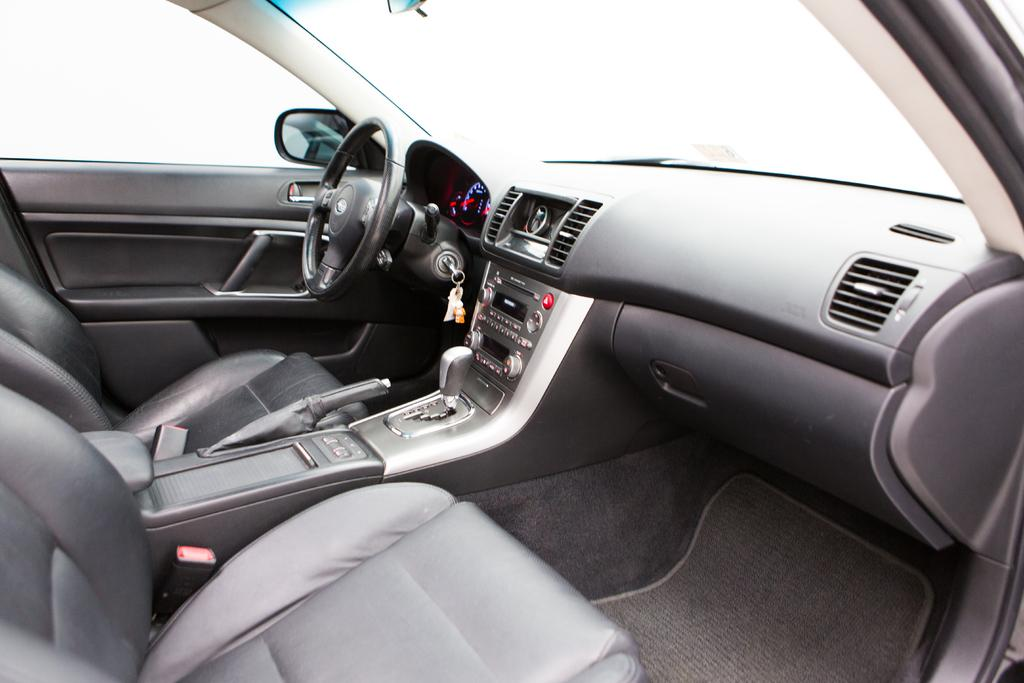What type of vehicle is shown in the image? The image shows the interior of a car. What is the main control device in the car? There is a steering wheel in the car. What is located near the steering wheel? A key is near the steering wheel. How can the driver change the car's speed? There is a gear in the car. How can the driver secure the car when parked? A hand brake is present in the car. How many seats are visible in the car? There are seats in the car. What is used to see the traffic behind the car? A side mirror is visible in the car. How can the driver listen to music in the car? A music system is present in the car. What type of judge is sitting in the car in the image? There is no judge present in the image; it shows the interior of a car with various features. 